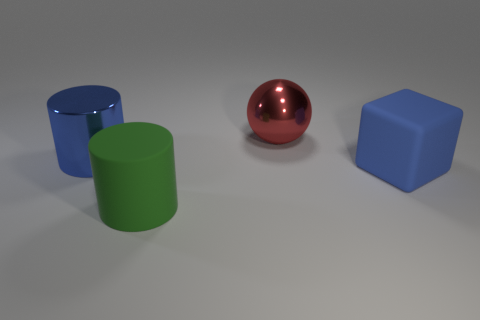Are there any small matte cylinders?
Give a very brief answer. No. Is there any other thing of the same color as the large metal cylinder?
Your answer should be very brief. Yes. The large blue object that is made of the same material as the large sphere is what shape?
Offer a very short reply. Cylinder. What is the color of the large metallic thing that is left of the red object behind the large cylinder in front of the blue matte thing?
Make the answer very short. Blue. Are there an equal number of matte blocks that are on the left side of the big shiny sphere and large red metal spheres?
Your response must be concise. No. Does the big metallic cylinder have the same color as the rubber thing that is on the right side of the green object?
Keep it short and to the point. Yes. Is there a ball on the left side of the object in front of the rubber thing that is to the right of the red ball?
Keep it short and to the point. No. Are there fewer large cylinders behind the shiny cylinder than green rubber cylinders?
Ensure brevity in your answer.  Yes. How many other objects are there of the same shape as the big blue metal object?
Keep it short and to the point. 1. What number of things are big objects in front of the blue metal cylinder or big metallic things to the left of the big sphere?
Provide a short and direct response. 3. 